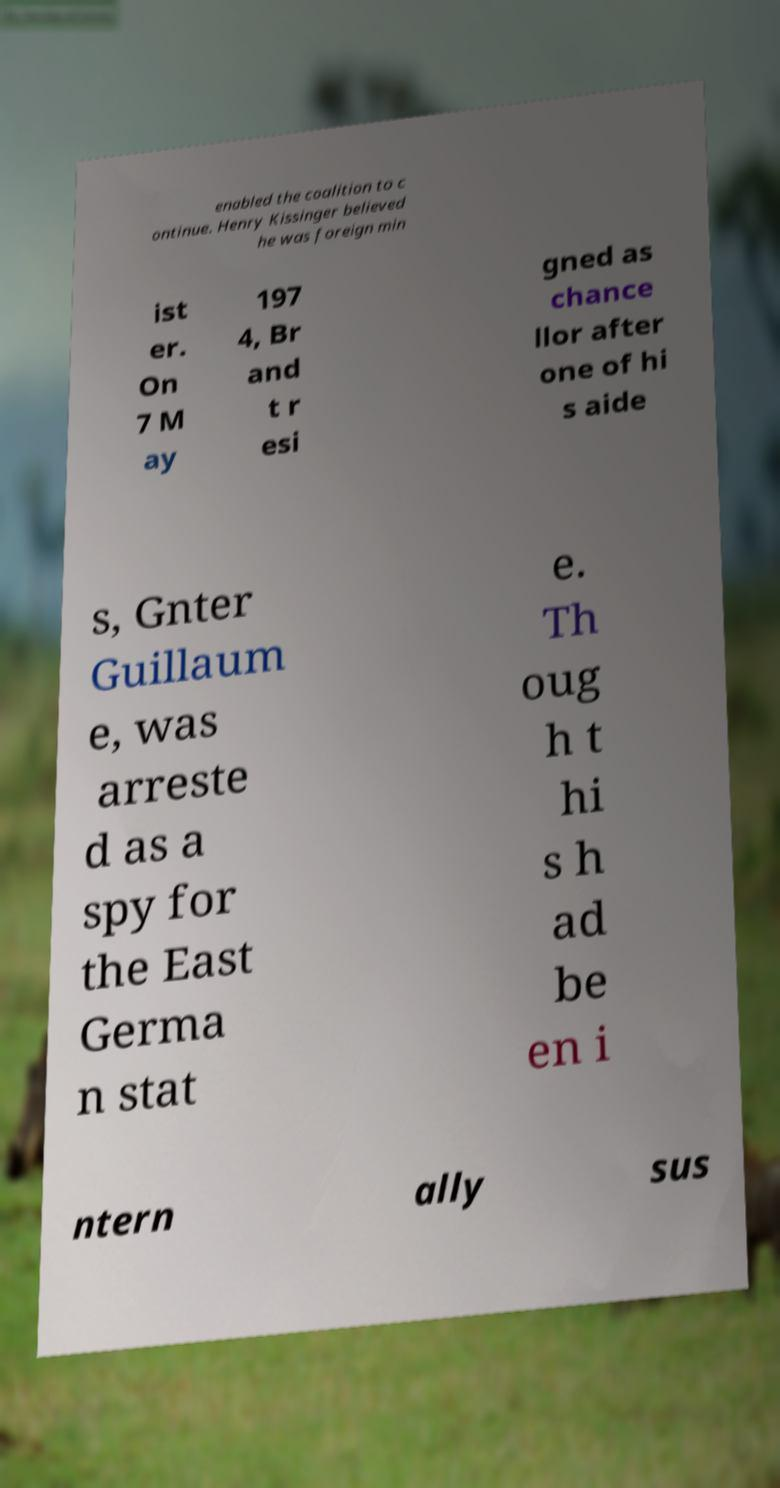Please read and relay the text visible in this image. What does it say? enabled the coalition to c ontinue. Henry Kissinger believed he was foreign min ist er. On 7 M ay 197 4, Br and t r esi gned as chance llor after one of hi s aide s, Gnter Guillaum e, was arreste d as a spy for the East Germa n stat e. Th oug h t hi s h ad be en i ntern ally sus 